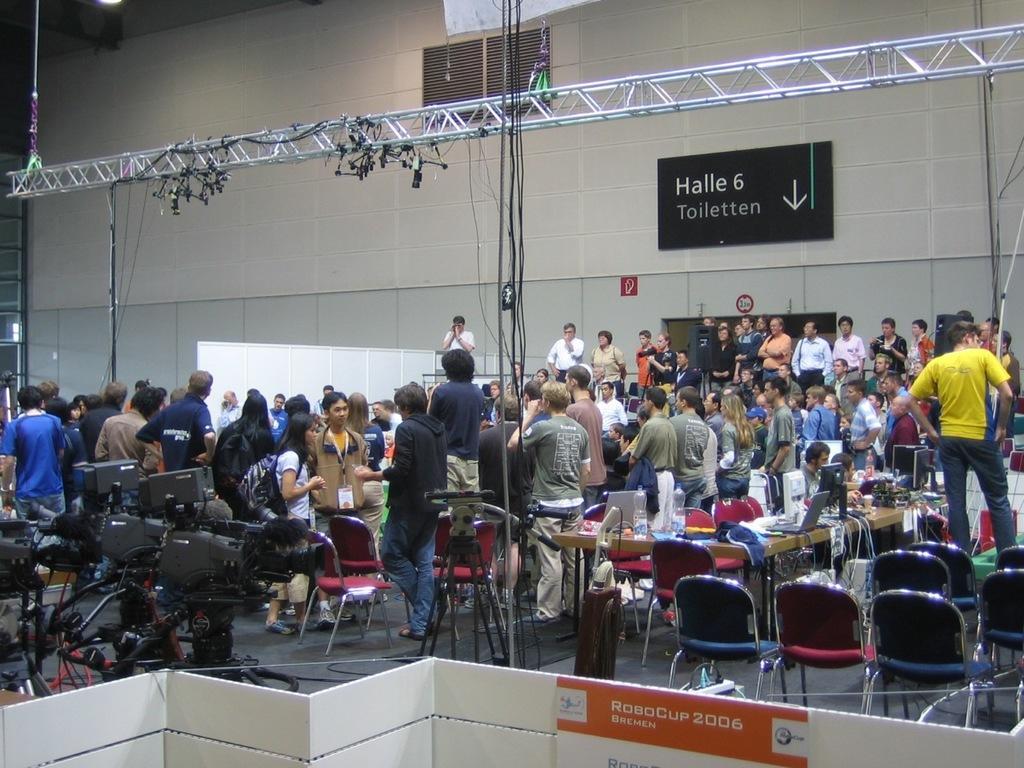Please provide a concise description of this image. In the picture I can see group of people are standing on the floor. I can also see chairs, wires, cameras, objects attached to the wall and some other objects on the floor. 